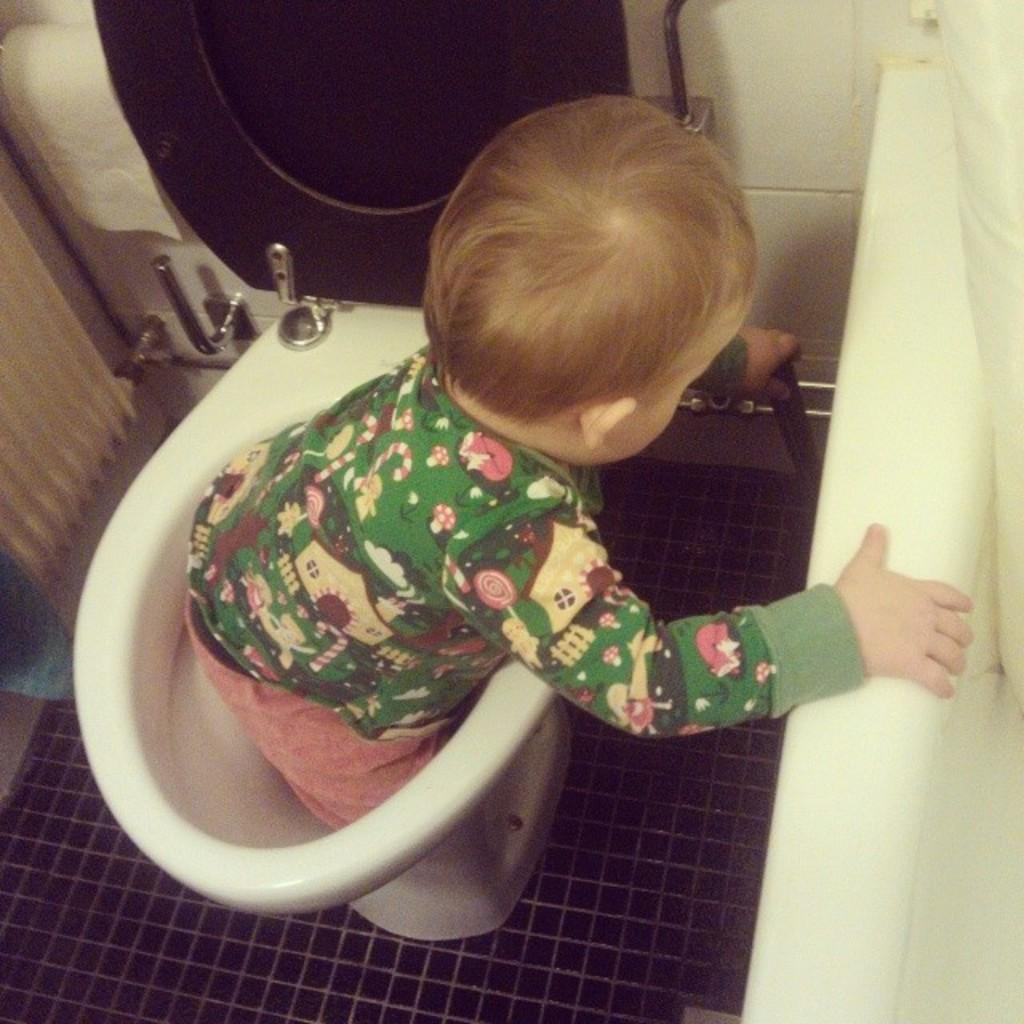What is the main subject of the image? The main subject of the image is a kid. Where is the kid located in the image? The kid is standing in a western toilet. What can be seen behind the toilet in the image? There is a wall behind the toilet. Reasoning: Let' Let's think step by step in order to produce the conversation. We start by identifying the main subject of the image, which is the kid. Then, we describe the kid's location and the specific type of toilet they are standing in. Finally, we mention the wall that is visible behind the toilet. Each question is designed to elicit a specific detail about the image that is known from the provided facts. Absurd Question/Answer: What type of poison is the kid holding in the image? There is no poison present in the image; the kid is standing in a western toilet. Can you see any bones in the image? There are no bones visible in the image; it features a kid standing in a toilet with a wall behind it. 